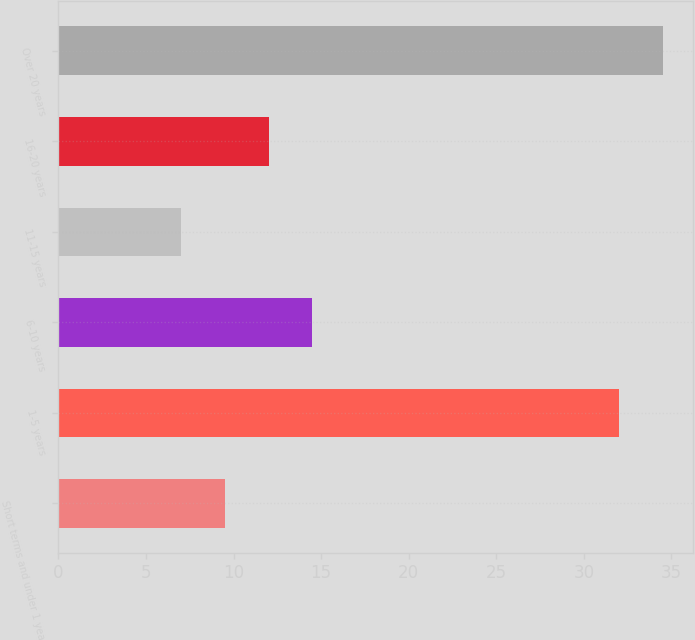Convert chart. <chart><loc_0><loc_0><loc_500><loc_500><bar_chart><fcel>Short terms and under 1 year<fcel>1-5 years<fcel>6-10 years<fcel>11-15 years<fcel>16-20 years<fcel>Over 20 years<nl><fcel>9.5<fcel>32<fcel>14.5<fcel>7<fcel>12<fcel>34.5<nl></chart> 